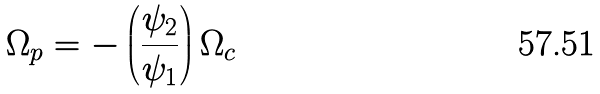<formula> <loc_0><loc_0><loc_500><loc_500>\Omega _ { p } = - \left ( \frac { \psi _ { 2 } } { \psi _ { 1 } } \right ) \Omega _ { c }</formula> 